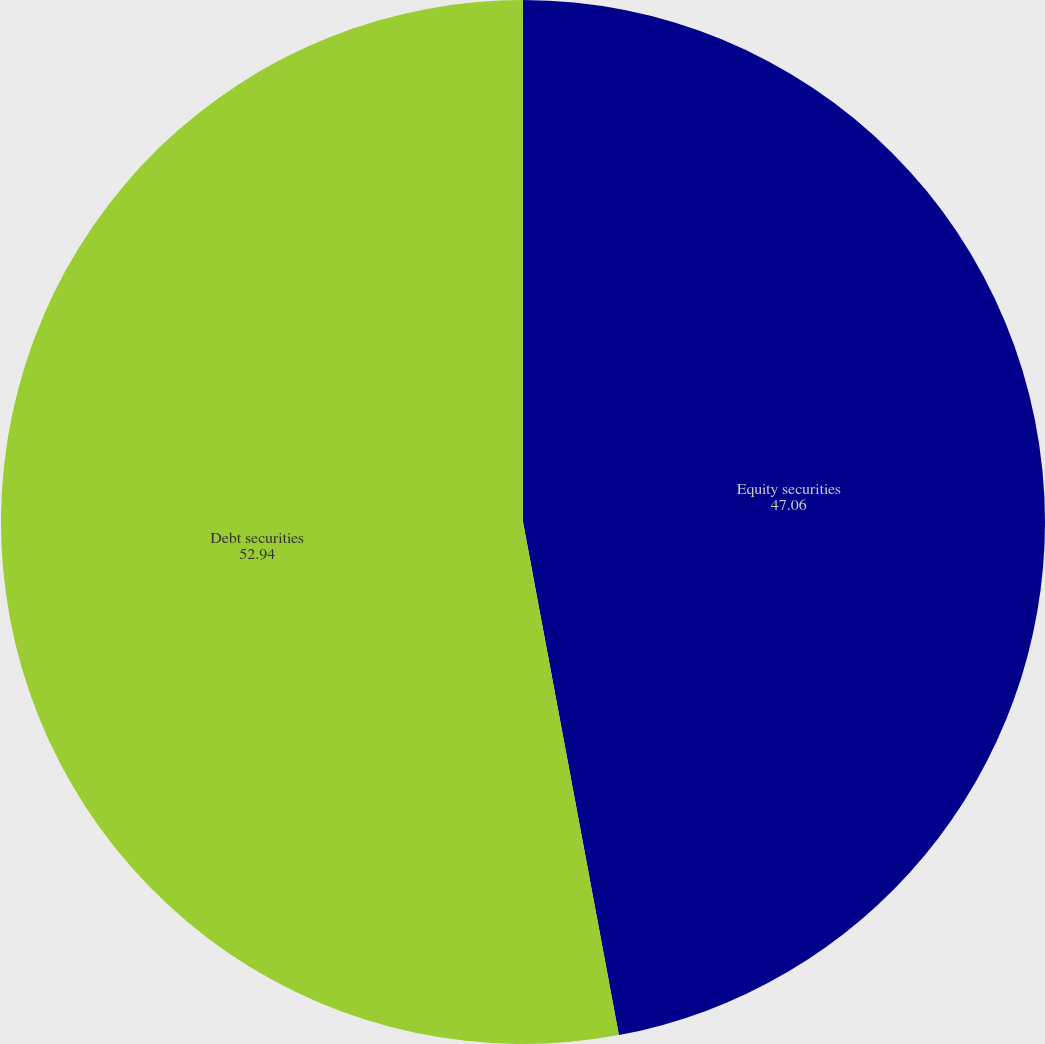<chart> <loc_0><loc_0><loc_500><loc_500><pie_chart><fcel>Equity securities<fcel>Debt securities<nl><fcel>47.06%<fcel>52.94%<nl></chart> 